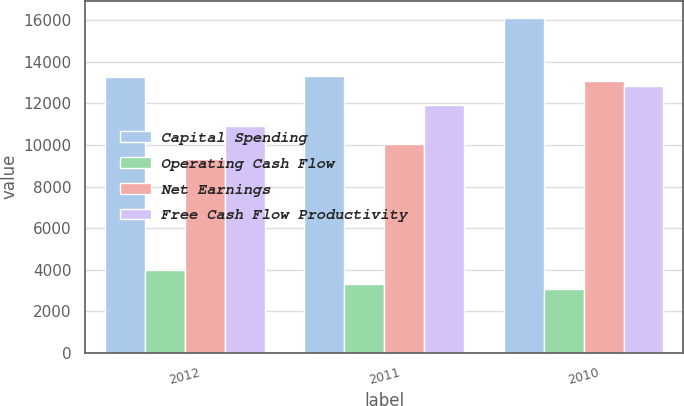<chart> <loc_0><loc_0><loc_500><loc_500><stacked_bar_chart><ecel><fcel>2012<fcel>2011<fcel>2010<nl><fcel>Capital Spending<fcel>13284<fcel>13330<fcel>16131<nl><fcel>Operating Cash Flow<fcel>3964<fcel>3306<fcel>3067<nl><fcel>Net Earnings<fcel>9320<fcel>10024<fcel>13064<nl><fcel>Free Cash Flow Productivity<fcel>10904<fcel>11927<fcel>12846<nl></chart> 